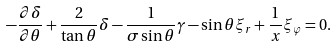<formula> <loc_0><loc_0><loc_500><loc_500>- \frac { \partial \delta } { \partial \theta } + \frac { 2 } { \tan \theta } \delta - \frac { 1 } { \sigma \sin \theta } \gamma - \sin \theta \xi _ { r } + \frac { 1 } { x } \xi _ { \varphi } = 0 .</formula> 